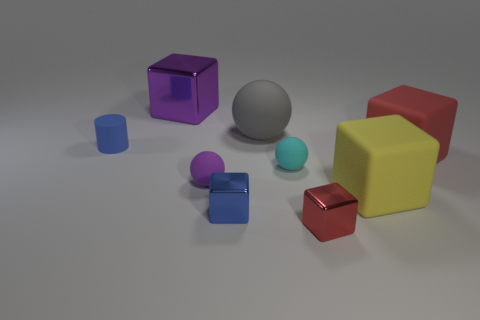There is a block that is both behind the yellow matte cube and in front of the small matte cylinder; what is its size?
Your answer should be compact. Large. The red rubber thing has what shape?
Provide a short and direct response. Cube. There is a sphere behind the cyan object; is there a gray rubber object that is to the right of it?
Give a very brief answer. No. There is a blue cube that is the same size as the cyan matte thing; what is its material?
Provide a succinct answer. Metal. Are there any red rubber balls that have the same size as the blue block?
Ensure brevity in your answer.  No. There is a small blue thing in front of the tiny purple thing; what is it made of?
Provide a succinct answer. Metal. Is the small blue object that is behind the cyan matte object made of the same material as the big yellow block?
Your response must be concise. Yes. There is a red metallic thing that is the same size as the purple rubber object; what shape is it?
Your response must be concise. Cube. How many small metallic objects have the same color as the small cylinder?
Provide a short and direct response. 1. Is the number of large red objects in front of the tiny purple sphere less than the number of big yellow matte blocks that are behind the tiny cylinder?
Offer a terse response. No. 